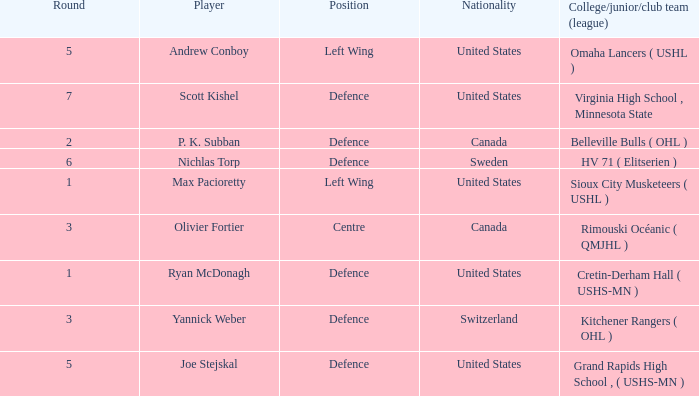Which College/junior/club team (league) was the player from Switzerland from? Kitchener Rangers ( OHL ). 